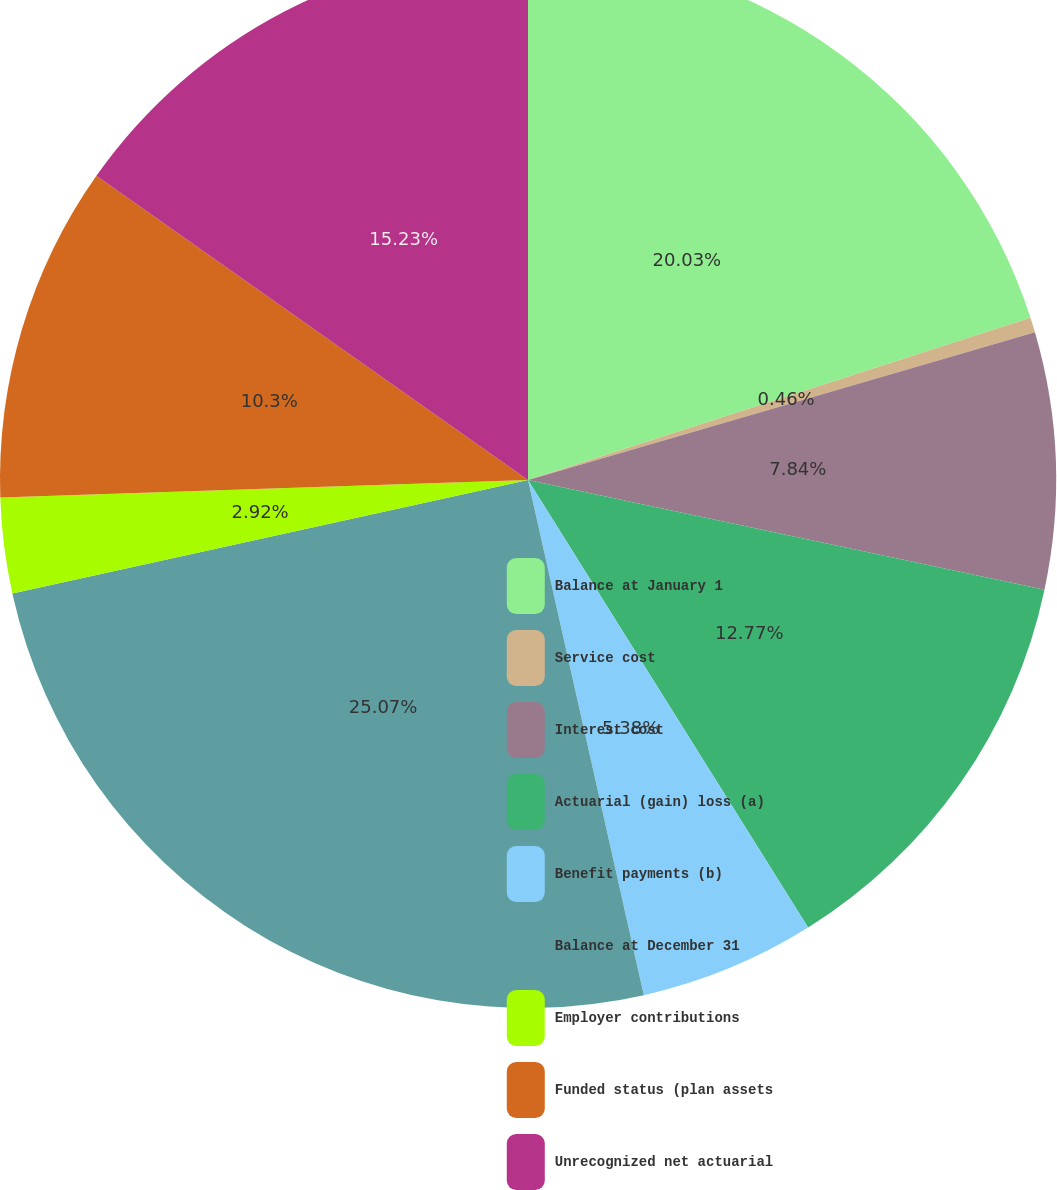Convert chart. <chart><loc_0><loc_0><loc_500><loc_500><pie_chart><fcel>Balance at January 1<fcel>Service cost<fcel>Interest cost<fcel>Actuarial (gain) loss (a)<fcel>Benefit payments (b)<fcel>Balance at December 31<fcel>Employer contributions<fcel>Funded status (plan assets<fcel>Unrecognized net actuarial<nl><fcel>20.03%<fcel>0.46%<fcel>7.84%<fcel>12.77%<fcel>5.38%<fcel>25.07%<fcel>2.92%<fcel>10.3%<fcel>15.23%<nl></chart> 